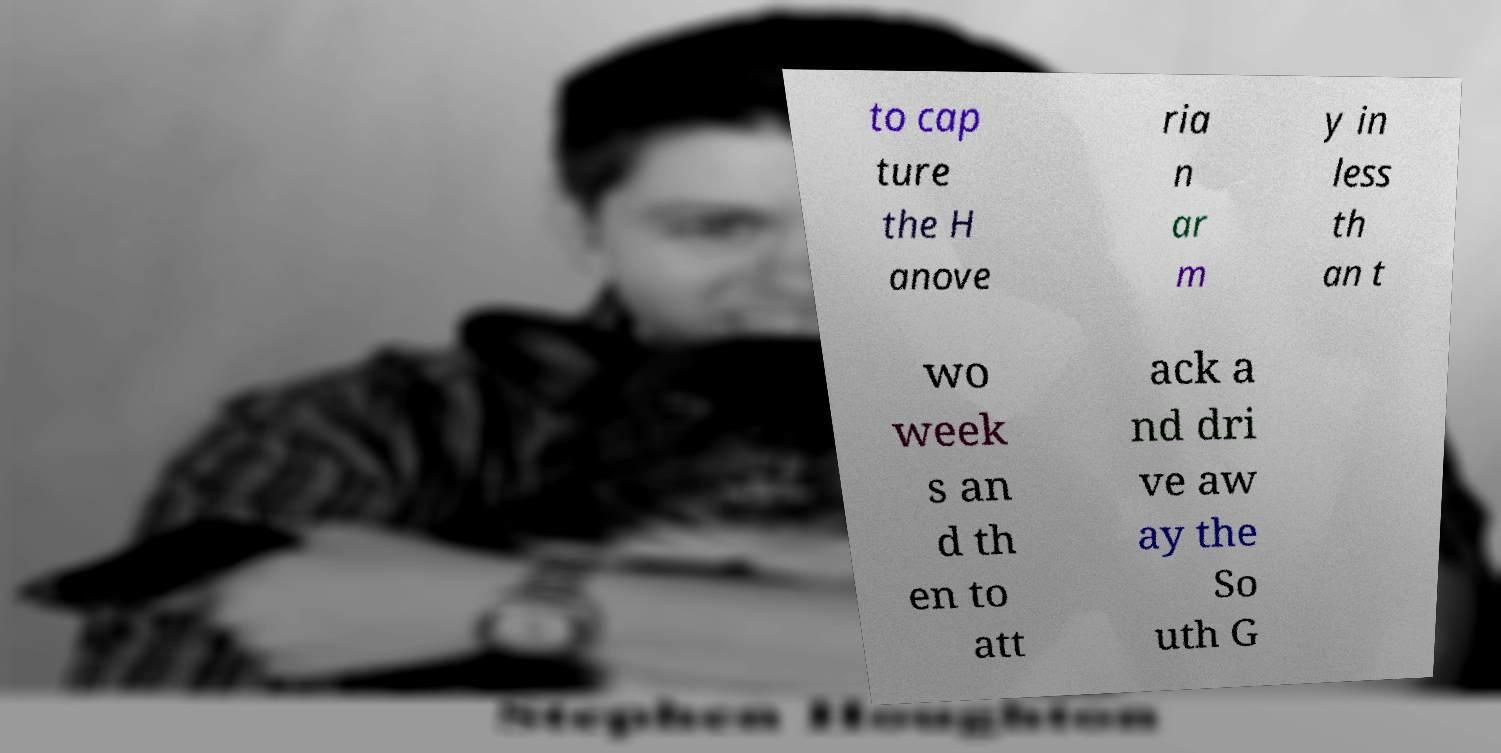Please read and relay the text visible in this image. What does it say? to cap ture the H anove ria n ar m y in less th an t wo week s an d th en to att ack a nd dri ve aw ay the So uth G 